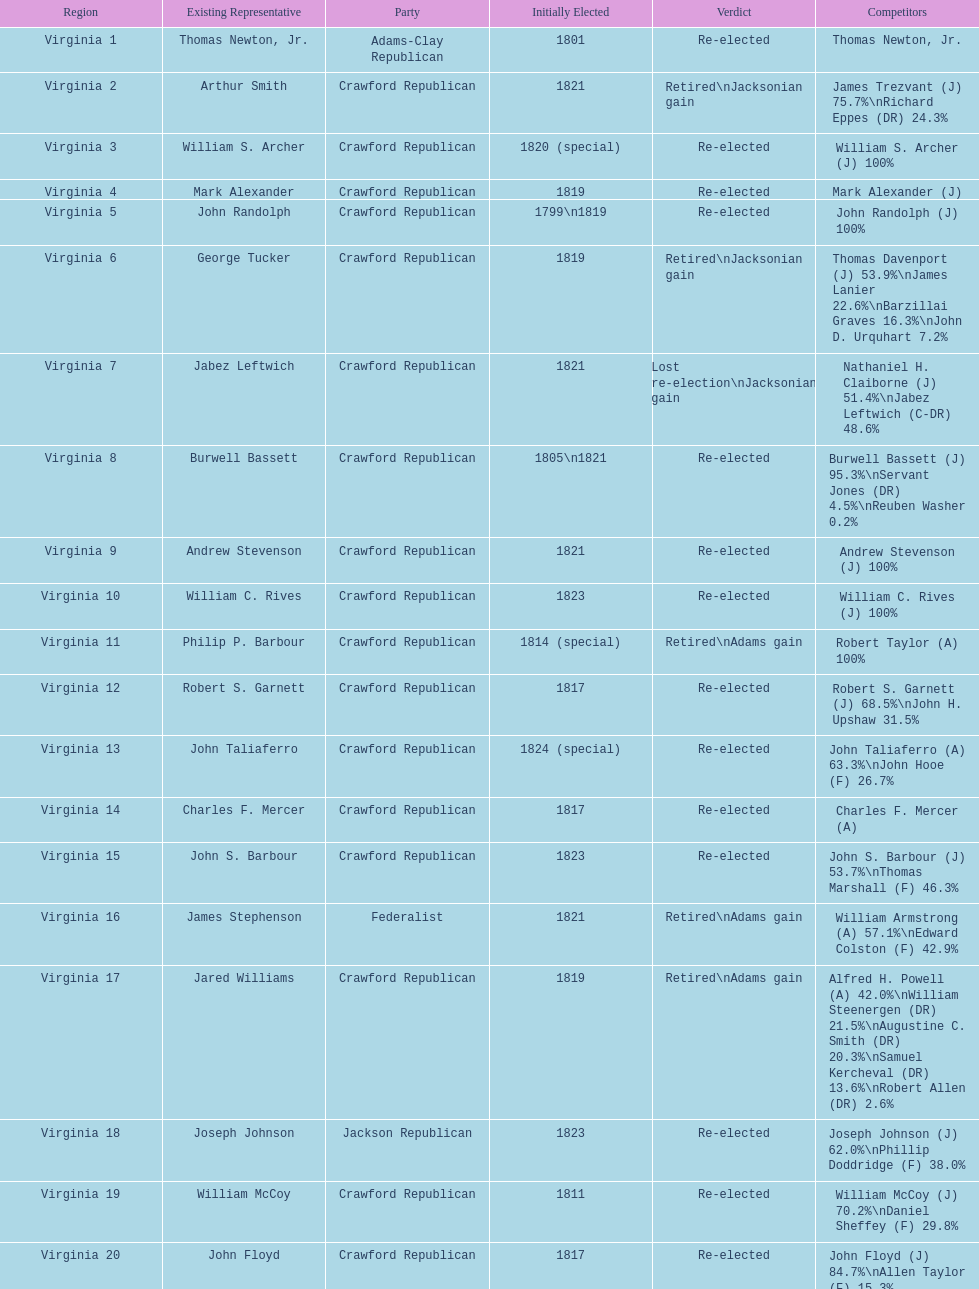What are the number of times re-elected is listed as the result? 15. 